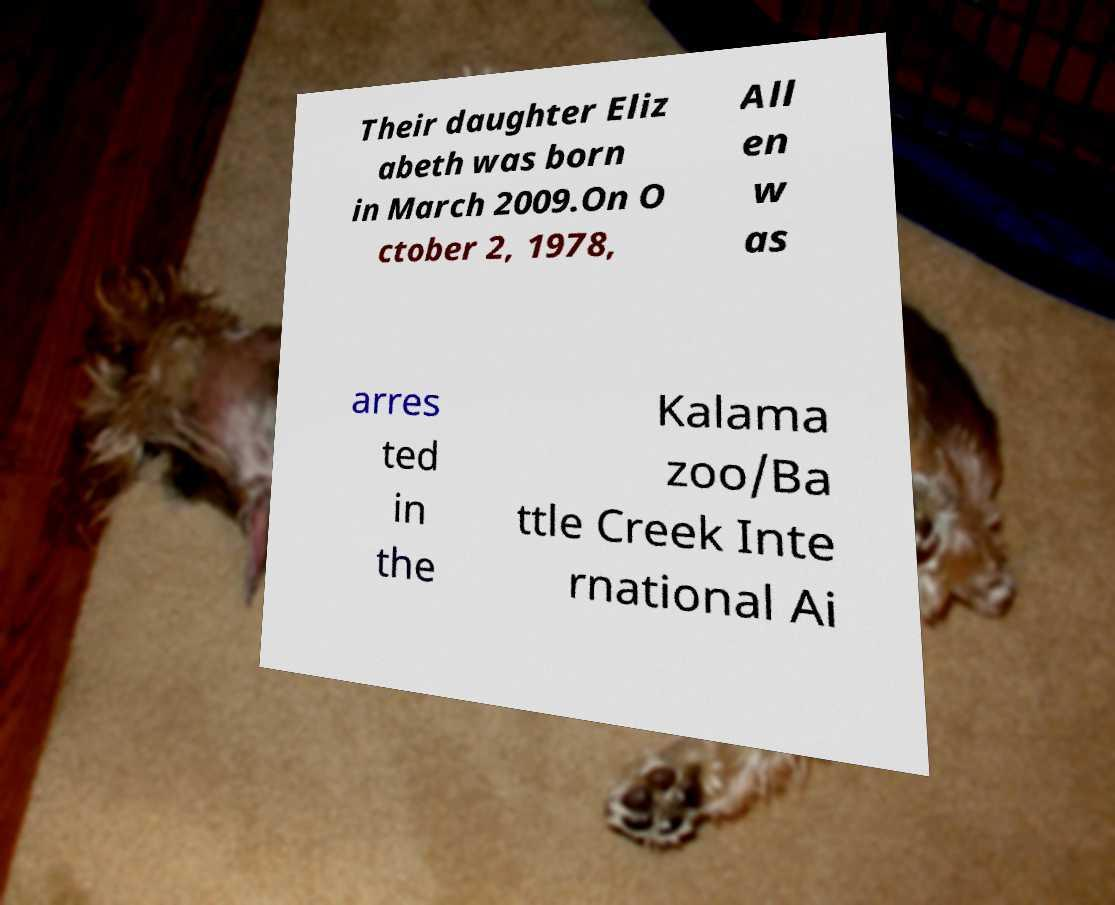For documentation purposes, I need the text within this image transcribed. Could you provide that? Their daughter Eliz abeth was born in March 2009.On O ctober 2, 1978, All en w as arres ted in the Kalama zoo/Ba ttle Creek Inte rnational Ai 